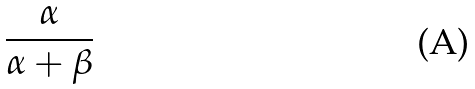Convert formula to latex. <formula><loc_0><loc_0><loc_500><loc_500>\frac { \alpha } { \alpha + \beta }</formula> 